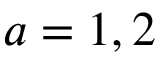<formula> <loc_0><loc_0><loc_500><loc_500>a = 1 , 2</formula> 